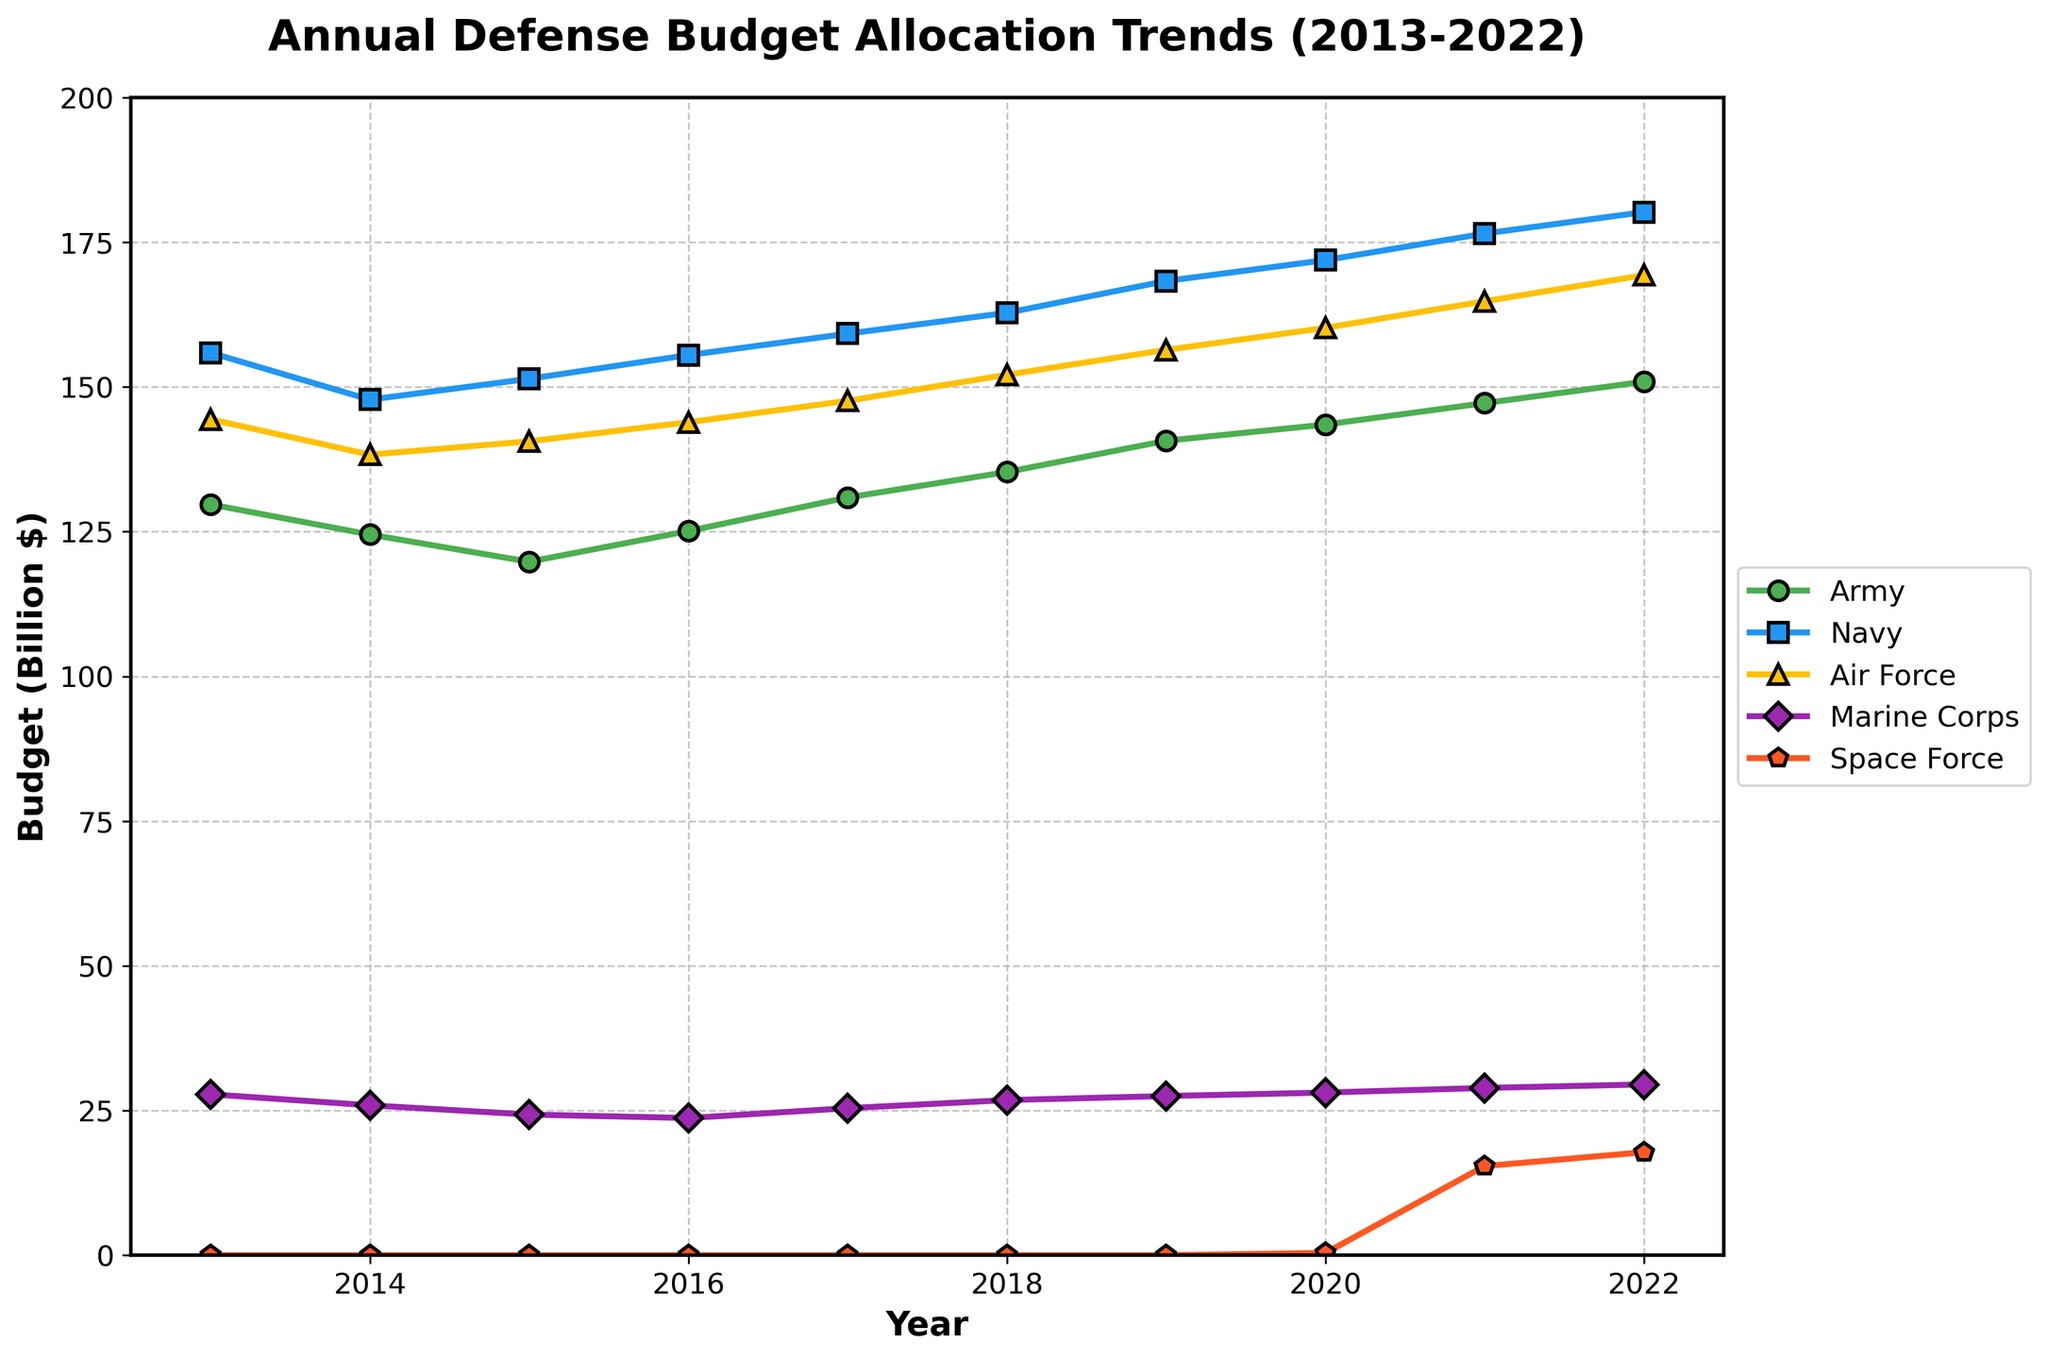What was the budget for the Army in 2018? The plot shows the defense budget allocation over the years. Locate the year 2018 on the x-axis and then find the corresponding value on the y-axis for the Army, which follows a green line with circle markers.
Answer: 135.3 Which military branch had the highest budget in 2022? To find this, look at the endpoints for each line in the year 2022 and compare the values. The Navy, marked with a blue line and square markers, has the highest value.
Answer: Navy How much did the Air Force's budget increase from 2013 to 2022? First, locate the Air Force's value in 2013 and 2022 on the graph (marked by the yellow line with triangle markers). Then, subtract the 2013 value from the 2022 value: 169.3 - 144.4 = 24.9.
Answer: 24.9 What is the combined budget of the Marine Corps and Space Force in 2021? Find the values for the Marine Corps and Space Force in 2021 by following their respective lines (purple with diamond markers and orange with pentagon markers). Add these values: 28.9 + 15.4 = 44.3.
Answer: 44.3 Which branch had the most significant budget increase from 2019 to 2020? Compare the change in budget values for each branch between 2019 and 2020. The Space Force, with an increase from 0 to 0.4, shows the most significant relative increase despite having the smallest absolute numbers.
Answer: Space Force What is the sum of the Army and Navy budgets in 2015? Locate the values for the Army and Navy in 2015 by following their respective lines (green with circle markers for Army and blue with square markers for Navy). Add these values: 119.8 + 151.4 = 271.2.
Answer: 271.2 In which year did the Navy reach a budget of approximately 160 billion dollars? Follow the blue line with square markers to find the year when the budget was closest to 160 billion dollars. This occurs in 2017, where the value is at 159.2 billion dollars.
Answer: 2017 Comparing the budget trends, did the Marine Corps budget show an increasing or decreasing trend over the decade 2013-2022? Observe the purple line with diamond markers representing the Marine Corps. The line trends upwards from 27.8 in 2013 to 29.5 in 2022, indicating an increasing trend.
Answer: Increasing What is the average Air Force budget over the years 2013 to 2022? Sum all the yearly Air Force budgets and divide by the number of years: (144.4 + 138.3 + 140.6 + 143.9 + 147.6 + 152.1 + 156.4 + 160.2 + 164.8 + 169.3) / 10 = 151.76.
Answer: 151.76 When did the Space Force first appear on the budget allocation chart, and what was its initial budget? Locate the first year the orange line with pentagon markers appears on the chart and observe the budget value. The Space Force first appears in 2020 with a budget of 0.4 billion dollars.
Answer: 2020, 0.4 